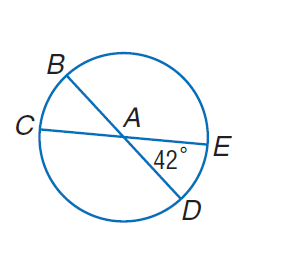Answer the mathemtical geometry problem and directly provide the correct option letter.
Question: In \odot A, m \angle E A D = 42. Find m \widehat B C.
Choices: A: 42 B: 48 C: 52 D: 108 A 